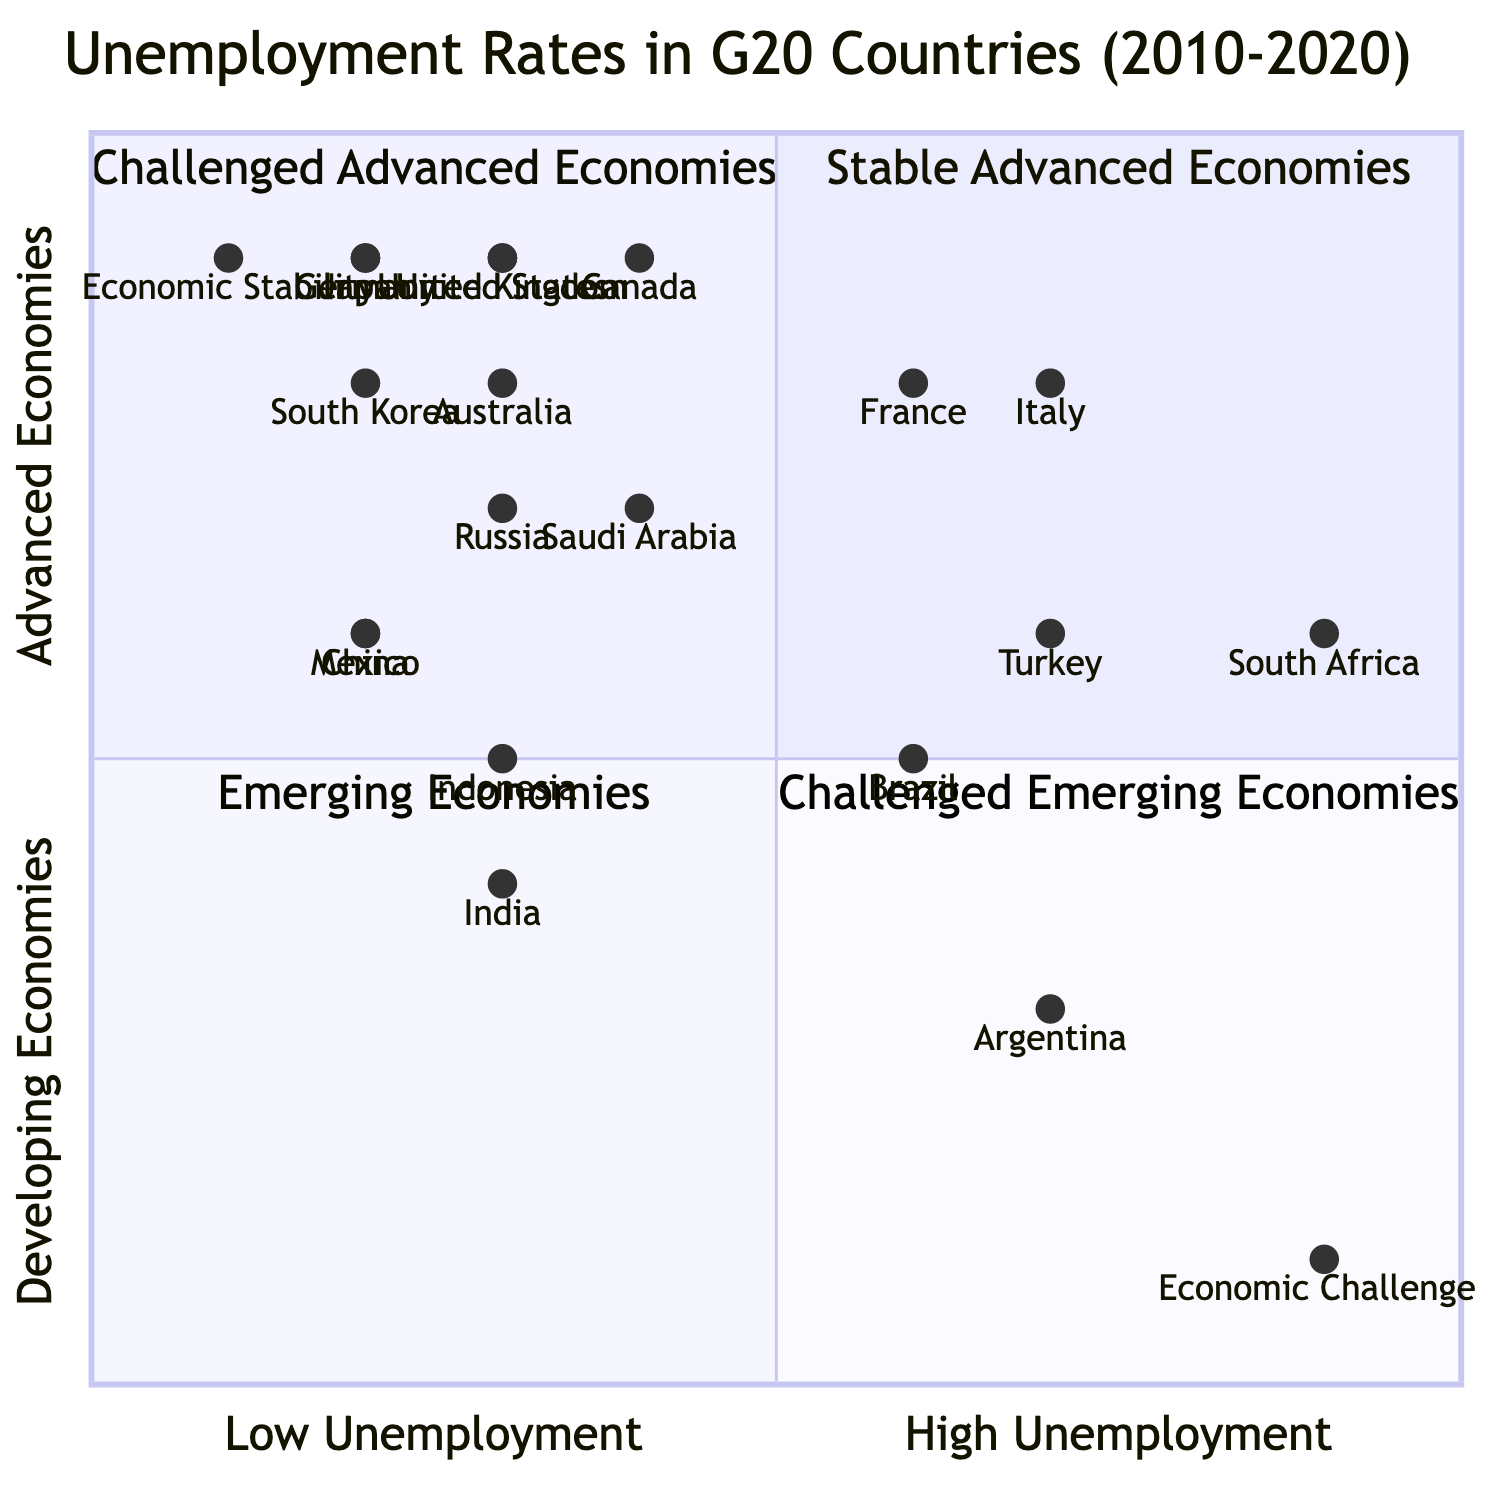What is the unemployment rate for Argentina? The diagram indicates that Argentina's unemployment rate is represented at coordinates [0.7, 0.3]. Therefore, the unemployment rate is at 0.7.
Answer: 0.7 Which country is located in the Challenged Advanced Economies quadrant? By analyzing the coordinates of the countries within the Challenged Advanced Economies quadrant (quadrant 2), France at [0.6, 0.8] is one such example.
Answer: France How many countries are classified as Emerging Economies? The diagram shows the coordinates of countries in the Emerging Economies quadrant (quadrant 3). There are five countries: Brazil, India, Indonesia, South Africa, and Turkey.
Answer: 5 Which two countries have the lowest unemployment rates? From the diagram, when comparing the coordinates of countries, China at [0.2, 0.6] and Germany at [0.2, 0.9] have the lowest unemployment rates of 0.2.
Answer: China and Germany What is the unemployment rate of Economic Stability? The coordinate representation of Economic Stability is [0.1, 0.9], indicating the unemployment rate is 0.1.
Answer: 0.1 Which quadrant contains the highest percentage of unemployment? The Quadrant representing Economic Challenges shows the coordinates [0.9, 0.1], demonstrating this quadrant depicts the highest unemployment percentage.
Answer: Economic Challenges What is the unemployment rate range for Advanced Economies? The Advanced Economies section (quadrant 1 and 2) shows unemployment rates ranging from 0.2 (Germany) to 0.7 (Italy), indicating a range of 0.5.
Answer: 0.5 What does a higher unemployment percentage indicate in the context of this diagram? In this heat map context, a higher unemployment percentage typically indicates a country is facing more economic challenges, particularly those in the lower right quadrant indicating Economic Challenges.
Answer: Economic Challenges 